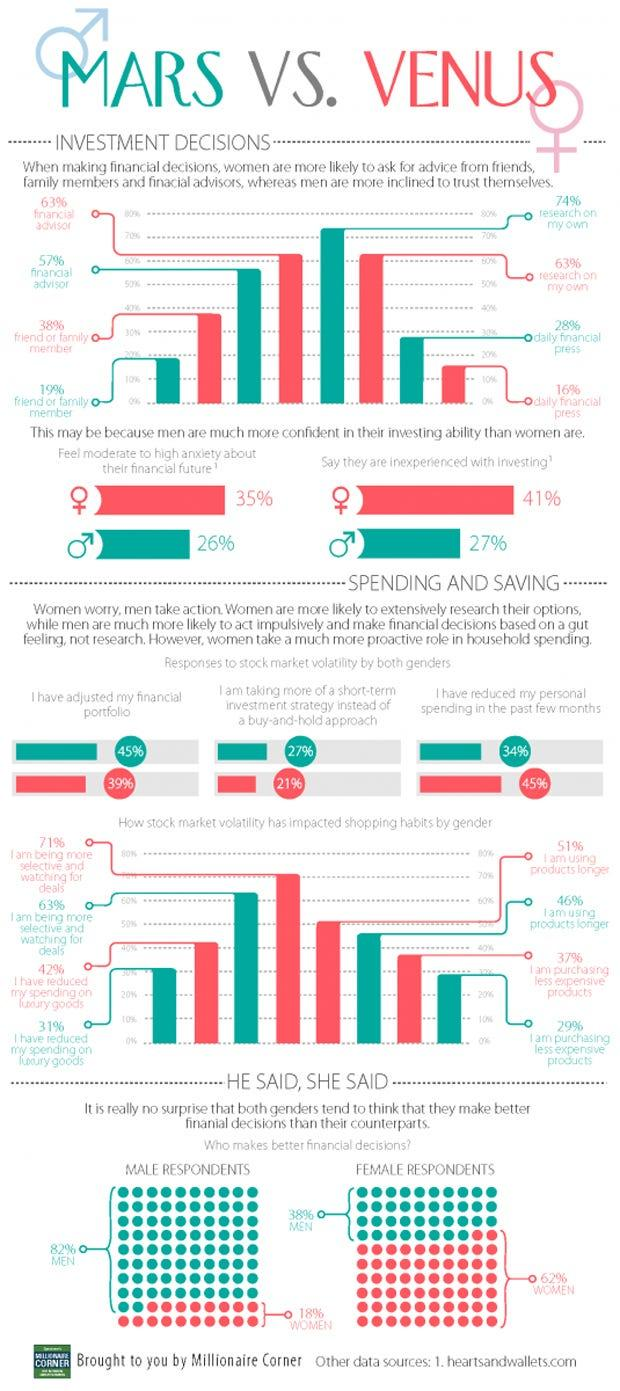Indicate a few pertinent items in this graphic. According to the given statistic, 38% of women seek financial advice from their friends or family members. According to the given statistic, approximately 26% of men report feeling moderate to high anxiety about their financial future. A recent survey has found that 34% of men have reduced their personal spending in the past few months. According to the data, approximately 35% of women have adjusted their financial portfolio. According to the bar graph, 74% of men research on their own. 